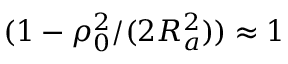Convert formula to latex. <formula><loc_0><loc_0><loc_500><loc_500>( 1 - \rho _ { 0 } ^ { 2 } / ( 2 R _ { a } ^ { 2 } ) ) \approx 1</formula> 